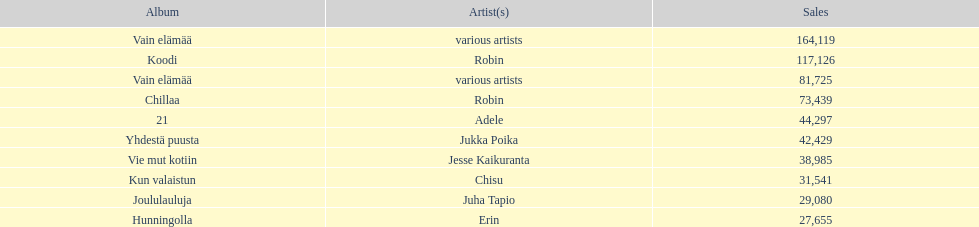What is the number of albums that sold over 50,000 copies this year? 4. 